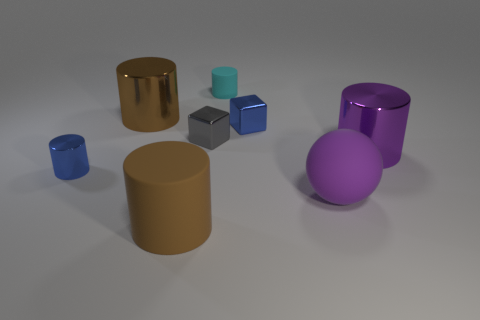Subtract all brown cylinders. How many cylinders are left? 3 Subtract all rubber cylinders. How many cylinders are left? 3 Subtract all gray cylinders. Subtract all blue cubes. How many cylinders are left? 5 Add 1 tiny cyan things. How many objects exist? 9 Subtract all balls. How many objects are left? 7 Add 1 small cyan matte cylinders. How many small cyan matte cylinders exist? 2 Subtract 0 red cylinders. How many objects are left? 8 Subtract all big rubber spheres. Subtract all small cyan matte blocks. How many objects are left? 7 Add 6 small gray cubes. How many small gray cubes are left? 7 